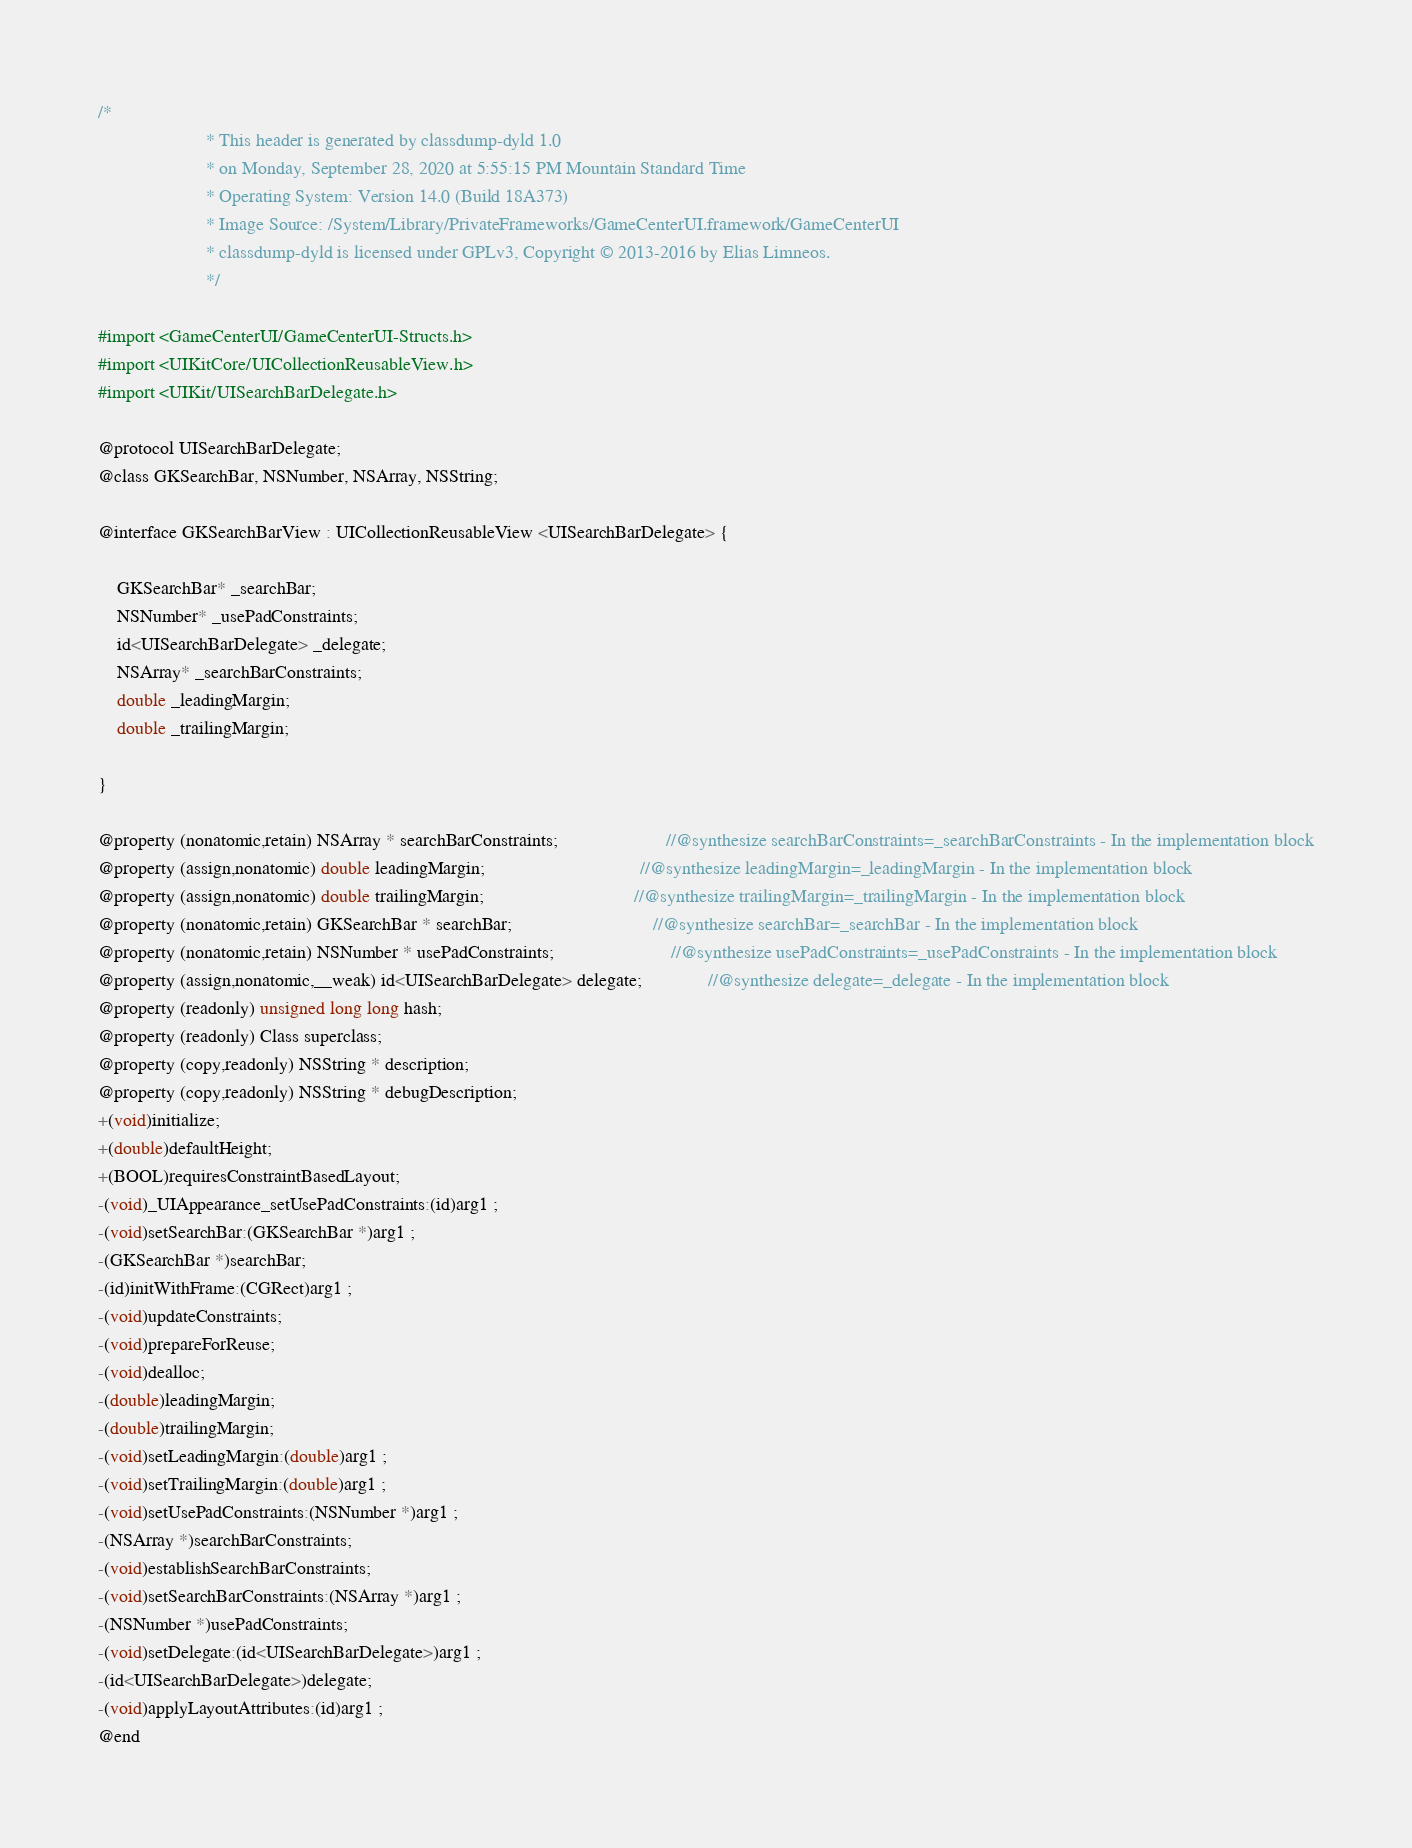<code> <loc_0><loc_0><loc_500><loc_500><_C_>/*
                       * This header is generated by classdump-dyld 1.0
                       * on Monday, September 28, 2020 at 5:55:15 PM Mountain Standard Time
                       * Operating System: Version 14.0 (Build 18A373)
                       * Image Source: /System/Library/PrivateFrameworks/GameCenterUI.framework/GameCenterUI
                       * classdump-dyld is licensed under GPLv3, Copyright © 2013-2016 by Elias Limneos.
                       */

#import <GameCenterUI/GameCenterUI-Structs.h>
#import <UIKitCore/UICollectionReusableView.h>
#import <UIKit/UISearchBarDelegate.h>

@protocol UISearchBarDelegate;
@class GKSearchBar, NSNumber, NSArray, NSString;

@interface GKSearchBarView : UICollectionReusableView <UISearchBarDelegate> {

	GKSearchBar* _searchBar;
	NSNumber* _usePadConstraints;
	id<UISearchBarDelegate> _delegate;
	NSArray* _searchBarConstraints;
	double _leadingMargin;
	double _trailingMargin;

}

@property (nonatomic,retain) NSArray * searchBarConstraints;                       //@synthesize searchBarConstraints=_searchBarConstraints - In the implementation block
@property (assign,nonatomic) double leadingMargin;                                 //@synthesize leadingMargin=_leadingMargin - In the implementation block
@property (assign,nonatomic) double trailingMargin;                                //@synthesize trailingMargin=_trailingMargin - In the implementation block
@property (nonatomic,retain) GKSearchBar * searchBar;                              //@synthesize searchBar=_searchBar - In the implementation block
@property (nonatomic,retain) NSNumber * usePadConstraints;                         //@synthesize usePadConstraints=_usePadConstraints - In the implementation block
@property (assign,nonatomic,__weak) id<UISearchBarDelegate> delegate;              //@synthesize delegate=_delegate - In the implementation block
@property (readonly) unsigned long long hash; 
@property (readonly) Class superclass; 
@property (copy,readonly) NSString * description; 
@property (copy,readonly) NSString * debugDescription; 
+(void)initialize;
+(double)defaultHeight;
+(BOOL)requiresConstraintBasedLayout;
-(void)_UIAppearance_setUsePadConstraints:(id)arg1 ;
-(void)setSearchBar:(GKSearchBar *)arg1 ;
-(GKSearchBar *)searchBar;
-(id)initWithFrame:(CGRect)arg1 ;
-(void)updateConstraints;
-(void)prepareForReuse;
-(void)dealloc;
-(double)leadingMargin;
-(double)trailingMargin;
-(void)setLeadingMargin:(double)arg1 ;
-(void)setTrailingMargin:(double)arg1 ;
-(void)setUsePadConstraints:(NSNumber *)arg1 ;
-(NSArray *)searchBarConstraints;
-(void)establishSearchBarConstraints;
-(void)setSearchBarConstraints:(NSArray *)arg1 ;
-(NSNumber *)usePadConstraints;
-(void)setDelegate:(id<UISearchBarDelegate>)arg1 ;
-(id<UISearchBarDelegate>)delegate;
-(void)applyLayoutAttributes:(id)arg1 ;
@end

</code> 